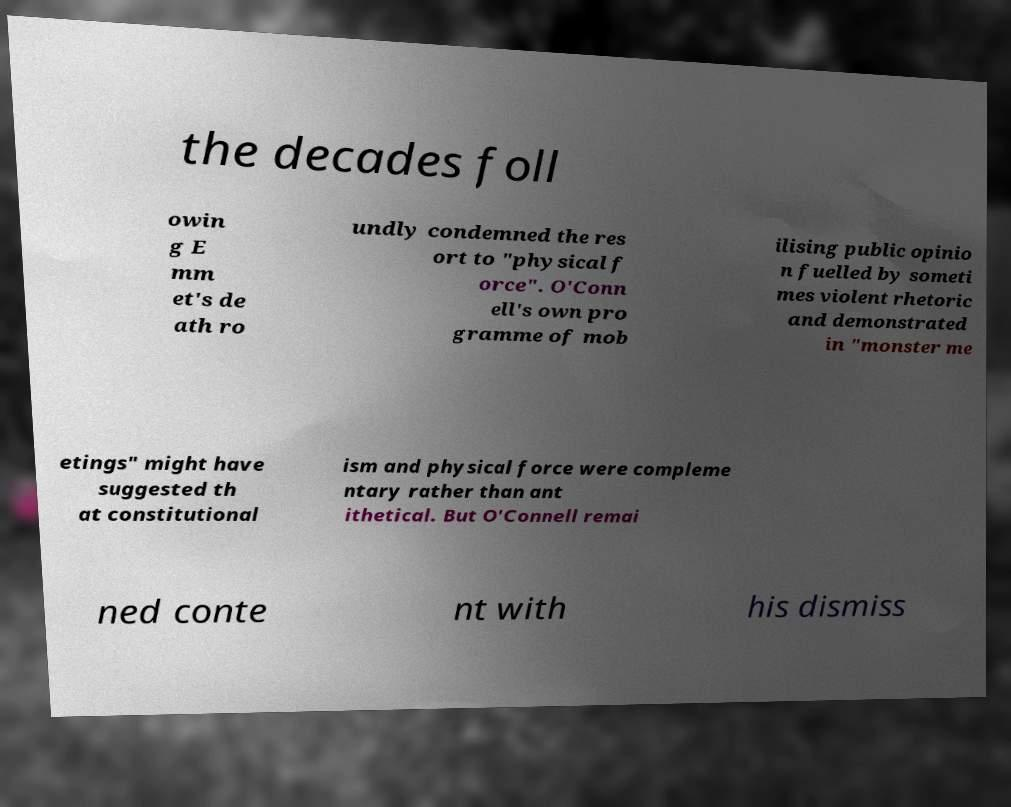What messages or text are displayed in this image? I need them in a readable, typed format. the decades foll owin g E mm et's de ath ro undly condemned the res ort to "physical f orce". O'Conn ell's own pro gramme of mob ilising public opinio n fuelled by someti mes violent rhetoric and demonstrated in "monster me etings" might have suggested th at constitutional ism and physical force were compleme ntary rather than ant ithetical. But O'Connell remai ned conte nt with his dismiss 